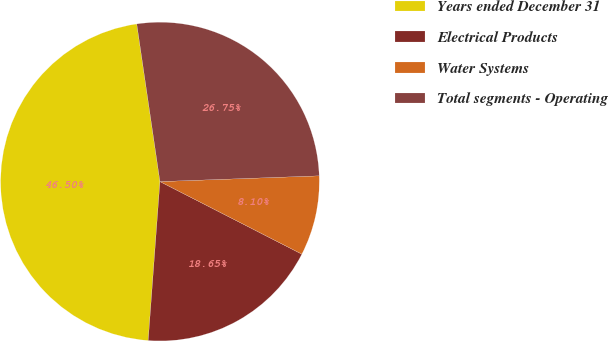<chart> <loc_0><loc_0><loc_500><loc_500><pie_chart><fcel>Years ended December 31<fcel>Electrical Products<fcel>Water Systems<fcel>Total segments - Operating<nl><fcel>46.5%<fcel>18.65%<fcel>8.1%<fcel>26.75%<nl></chart> 